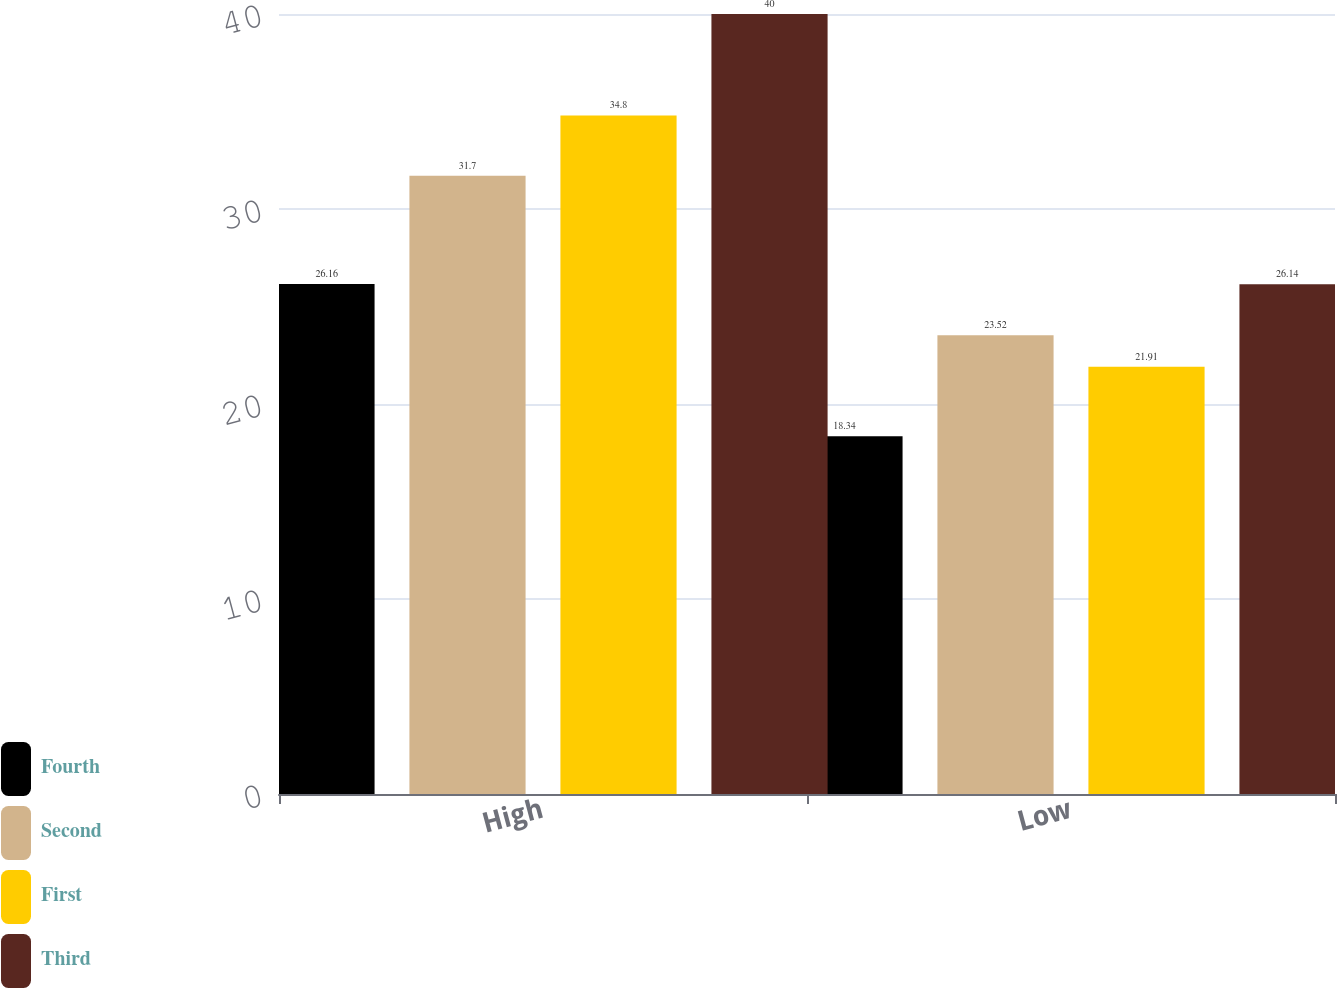Convert chart. <chart><loc_0><loc_0><loc_500><loc_500><stacked_bar_chart><ecel><fcel>High<fcel>Low<nl><fcel>Fourth<fcel>26.16<fcel>18.34<nl><fcel>Second<fcel>31.7<fcel>23.52<nl><fcel>First<fcel>34.8<fcel>21.91<nl><fcel>Third<fcel>40<fcel>26.14<nl></chart> 